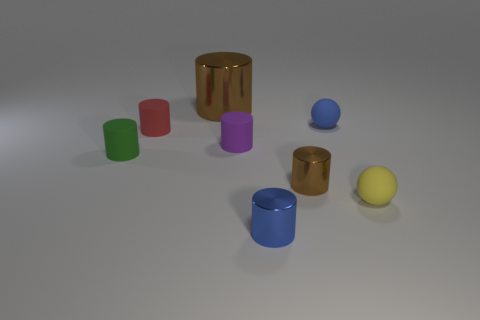What could be a real-world application for these objects? These objects resemble containers or storage units. In a real-world setting, they could serve as decorative holders for small items like pens and office supplies, or perhaps as part of a sorting game intended to teach children about colors and shapes. 